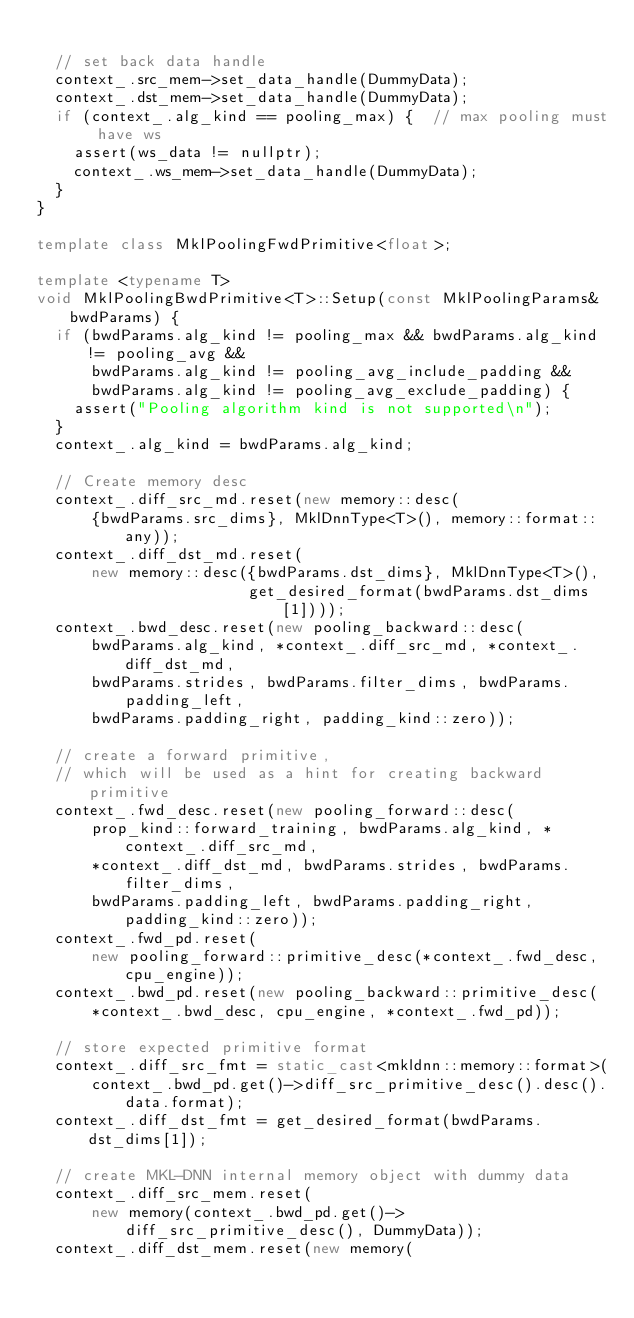<code> <loc_0><loc_0><loc_500><loc_500><_C++_>
  // set back data handle
  context_.src_mem->set_data_handle(DummyData);
  context_.dst_mem->set_data_handle(DummyData);
  if (context_.alg_kind == pooling_max) {  // max pooling must have ws
    assert(ws_data != nullptr);
    context_.ws_mem->set_data_handle(DummyData);
  }
}

template class MklPoolingFwdPrimitive<float>;

template <typename T>
void MklPoolingBwdPrimitive<T>::Setup(const MklPoolingParams& bwdParams) {
  if (bwdParams.alg_kind != pooling_max && bwdParams.alg_kind != pooling_avg &&
      bwdParams.alg_kind != pooling_avg_include_padding &&
      bwdParams.alg_kind != pooling_avg_exclude_padding) {
    assert("Pooling algorithm kind is not supported\n");
  }
  context_.alg_kind = bwdParams.alg_kind;

  // Create memory desc
  context_.diff_src_md.reset(new memory::desc(
      {bwdParams.src_dims}, MklDnnType<T>(), memory::format::any));
  context_.diff_dst_md.reset(
      new memory::desc({bwdParams.dst_dims}, MklDnnType<T>(),
                       get_desired_format(bwdParams.dst_dims[1])));
  context_.bwd_desc.reset(new pooling_backward::desc(
      bwdParams.alg_kind, *context_.diff_src_md, *context_.diff_dst_md,
      bwdParams.strides, bwdParams.filter_dims, bwdParams.padding_left,
      bwdParams.padding_right, padding_kind::zero));

  // create a forward primitive,
  // which will be used as a hint for creating backward primitive
  context_.fwd_desc.reset(new pooling_forward::desc(
      prop_kind::forward_training, bwdParams.alg_kind, *context_.diff_src_md,
      *context_.diff_dst_md, bwdParams.strides, bwdParams.filter_dims,
      bwdParams.padding_left, bwdParams.padding_right, padding_kind::zero));
  context_.fwd_pd.reset(
      new pooling_forward::primitive_desc(*context_.fwd_desc, cpu_engine));
  context_.bwd_pd.reset(new pooling_backward::primitive_desc(
      *context_.bwd_desc, cpu_engine, *context_.fwd_pd));

  // store expected primitive format
  context_.diff_src_fmt = static_cast<mkldnn::memory::format>(
      context_.bwd_pd.get()->diff_src_primitive_desc().desc().data.format);
  context_.diff_dst_fmt = get_desired_format(bwdParams.dst_dims[1]);

  // create MKL-DNN internal memory object with dummy data
  context_.diff_src_mem.reset(
      new memory(context_.bwd_pd.get()->diff_src_primitive_desc(), DummyData));
  context_.diff_dst_mem.reset(new memory(</code> 